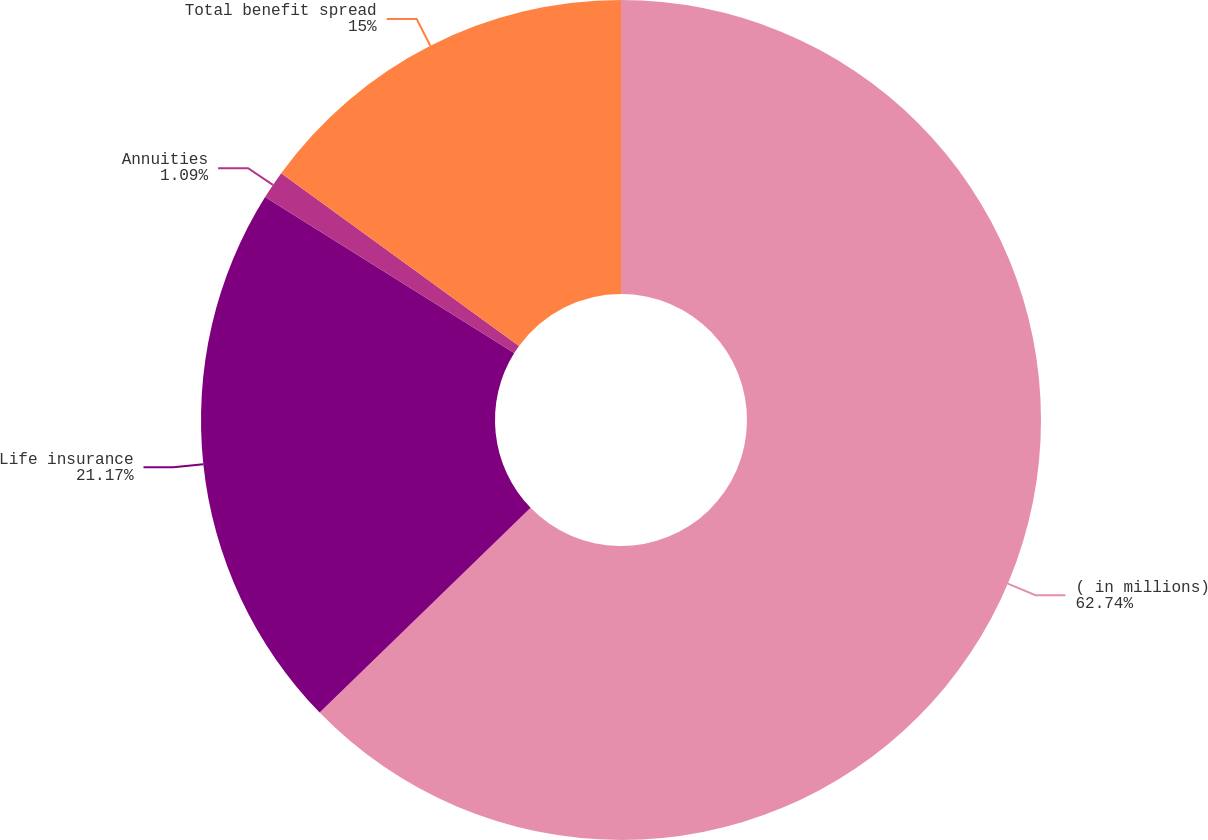Convert chart. <chart><loc_0><loc_0><loc_500><loc_500><pie_chart><fcel>( in millions)<fcel>Life insurance<fcel>Annuities<fcel>Total benefit spread<nl><fcel>62.73%<fcel>21.17%<fcel>1.09%<fcel>15.0%<nl></chart> 